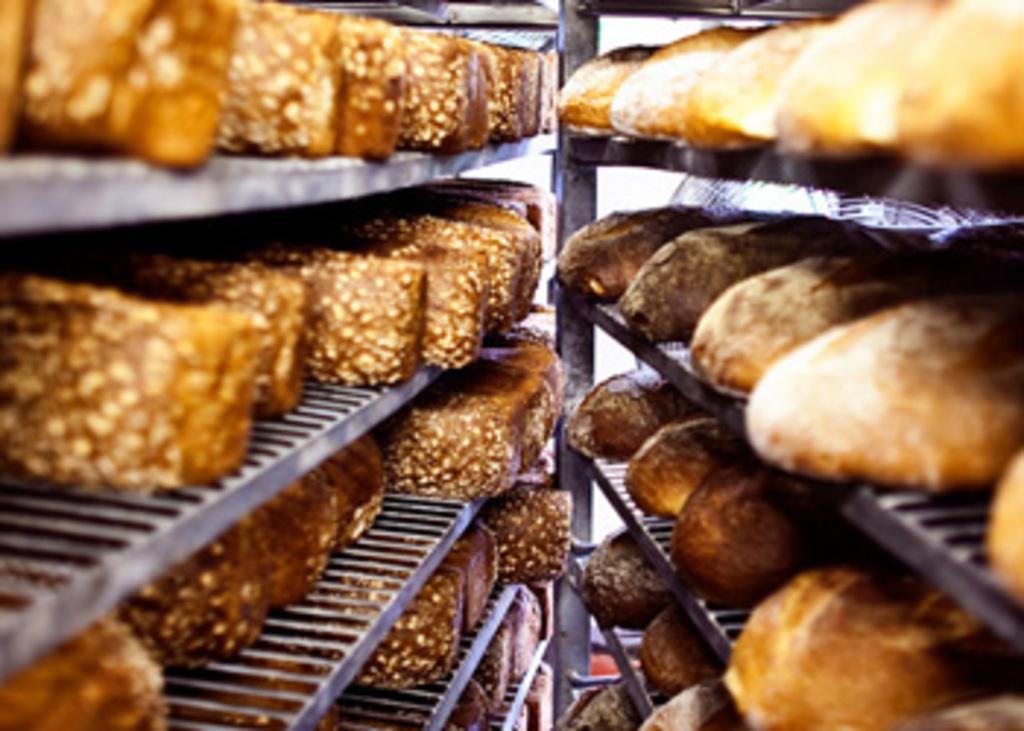Please provide a concise description of this image. In this image we can see group of food items in racks. 